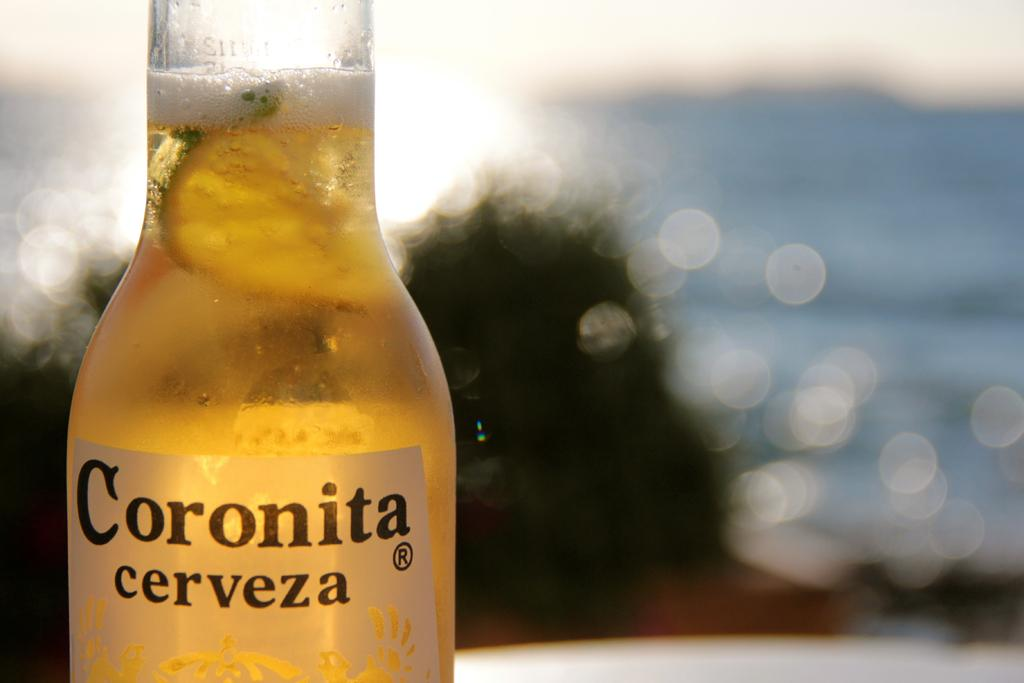<image>
Create a compact narrative representing the image presented. A bottle of Coronita cerveza with a lime slice floating in it. 